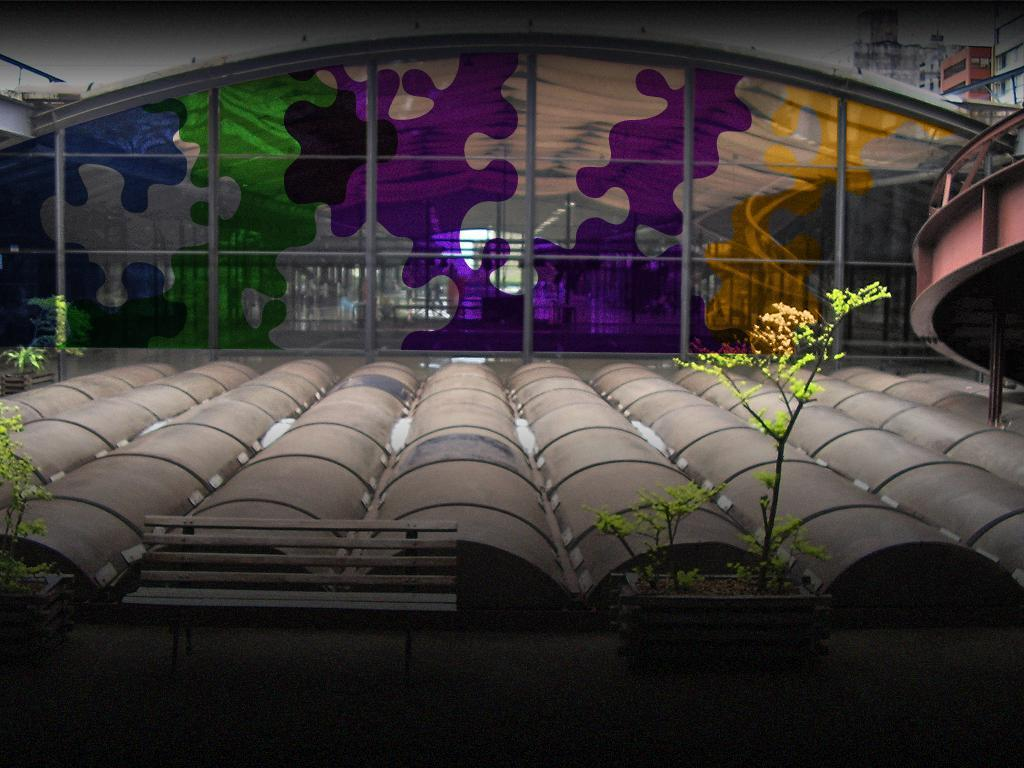What type of seating is visible in the image? There is a park bench in the image. What is located near the park bench? There is a plant beside the park bench. What material is the wall made of in the image? There is a glass wall in the image. What decorative element is present on the glass wall? There is a painting on the glass wall. What type of canvas is used for the throat of the cub in the image? There is no canvas, throat, or cub present in the image. 